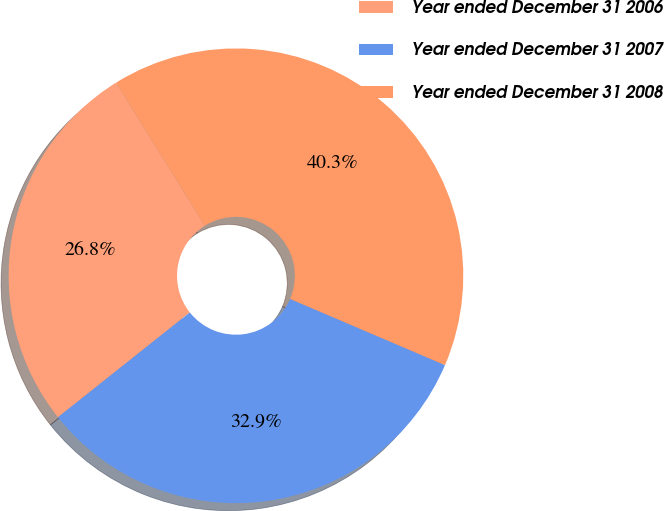Convert chart. <chart><loc_0><loc_0><loc_500><loc_500><pie_chart><fcel>Year ended December 31 2006<fcel>Year ended December 31 2007<fcel>Year ended December 31 2008<nl><fcel>26.85%<fcel>32.89%<fcel>40.27%<nl></chart> 